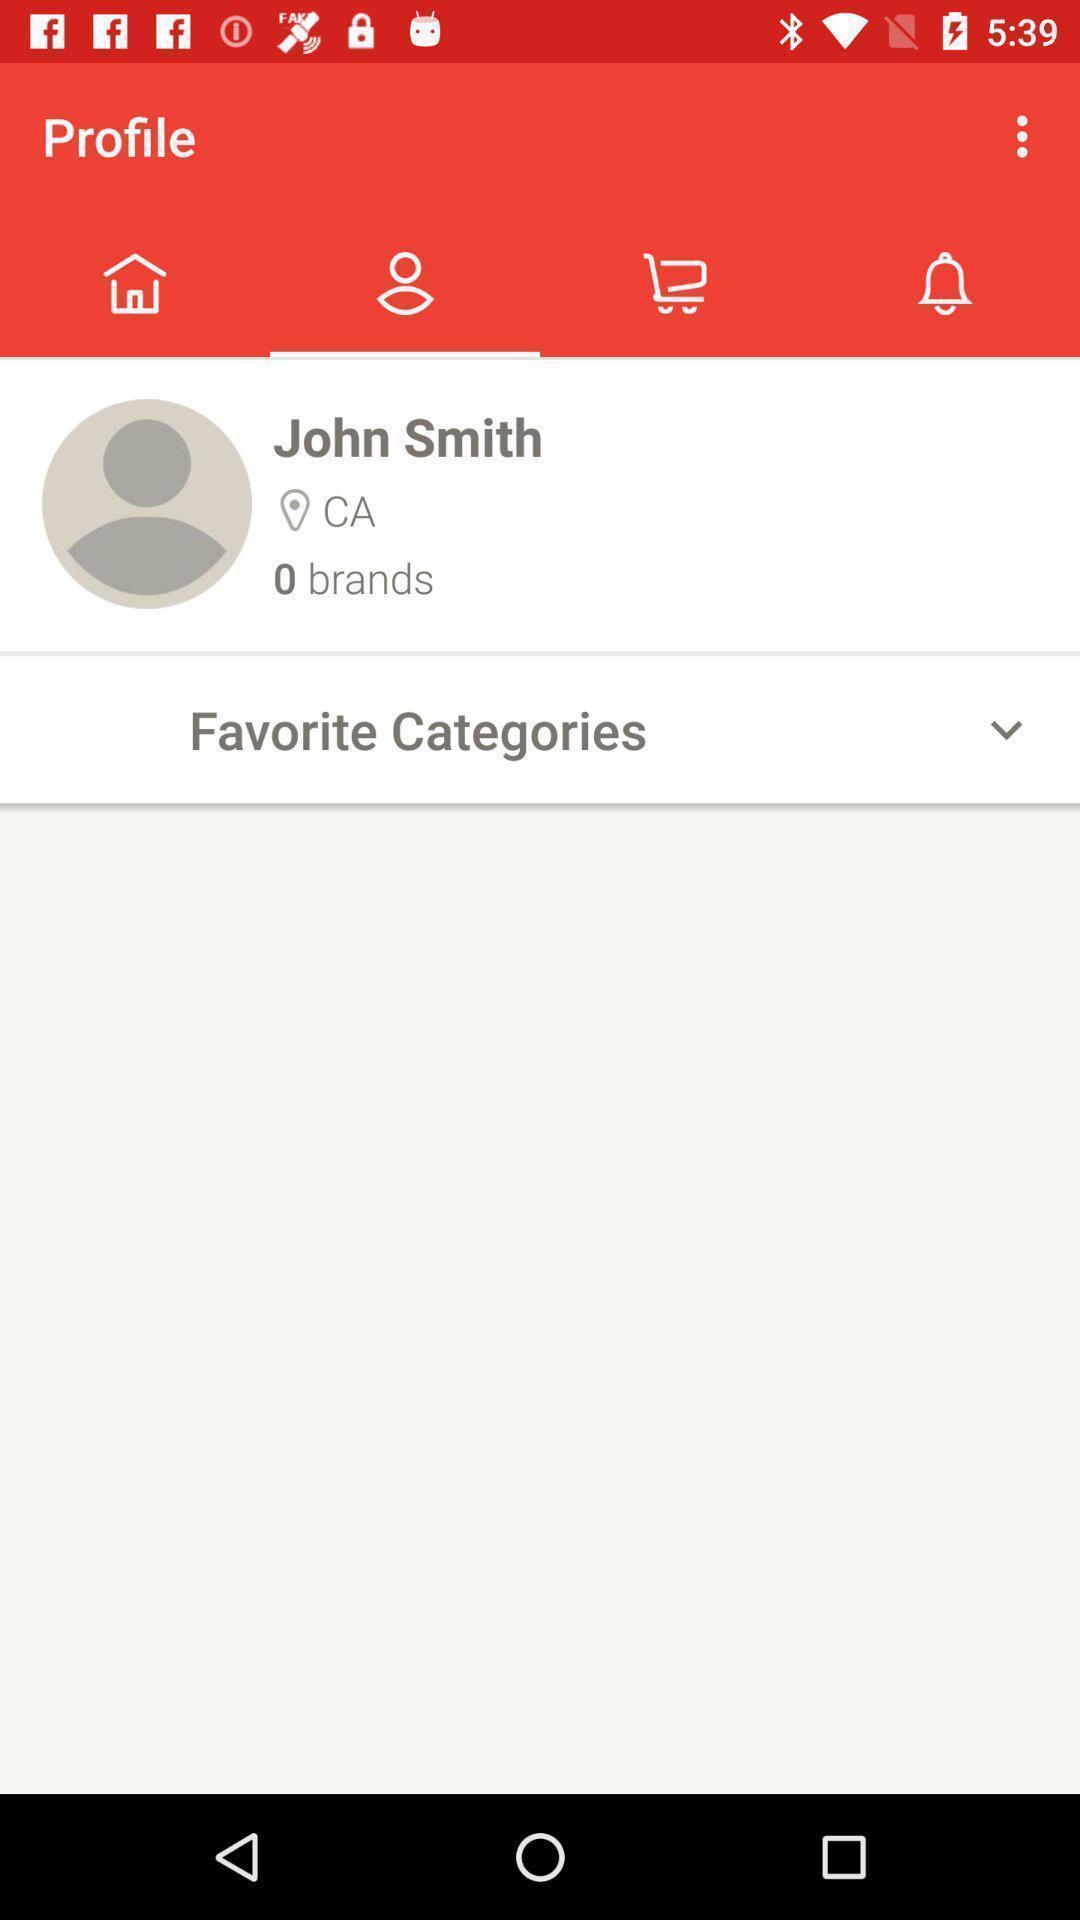What is the overall content of this screenshot? Person 's profile page. 